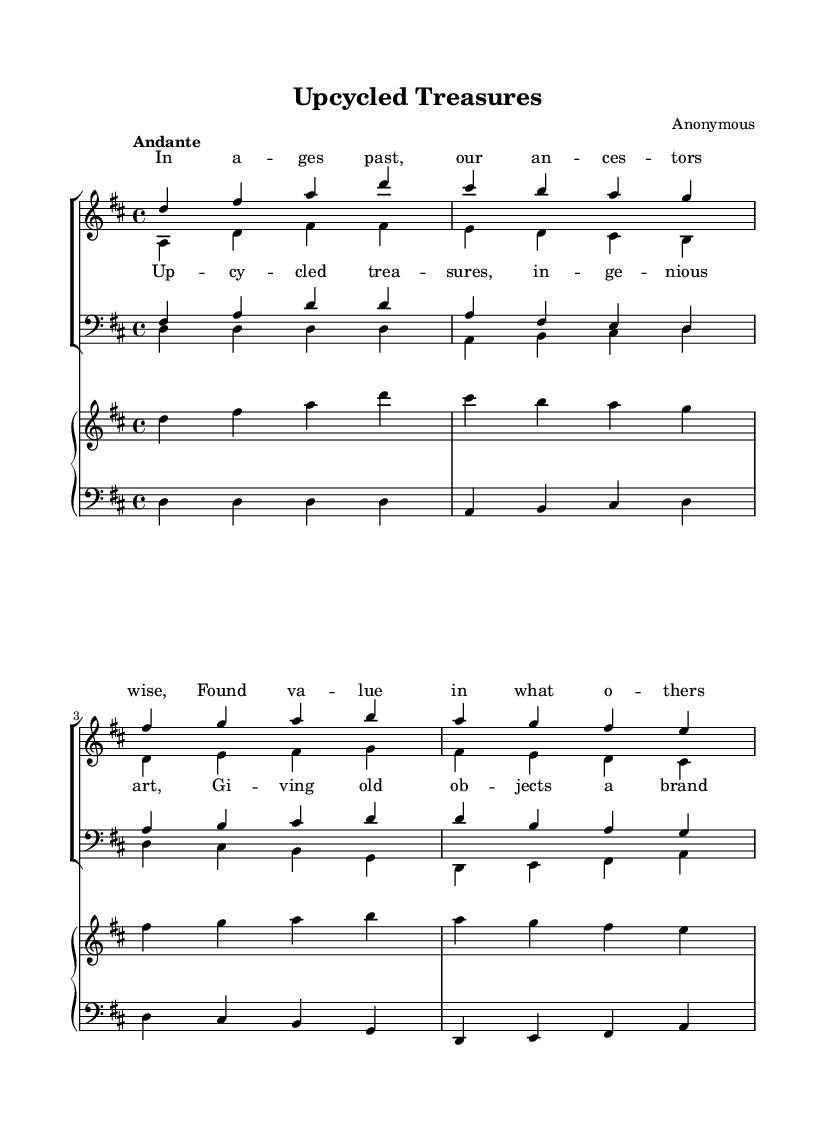What is the key signature of this music? The key signature is D major, as indicated by the two sharps (F# and C#) at the beginning of the staff.
Answer: D major What is the time signature of this music? The time signature is 4/4, shown at the beginning of the sheet music, indicating that there are four beats in each measure and each quarter note gets one beat.
Answer: 4/4 What is the tempo marking of this piece? The tempo marking is "Andante," which is indicated above the staff; it suggests a moderate pace.
Answer: Andante How many parts are there for the choir in this sheet music? The choir consists of four parts: soprano, alto, tenor, and bass, which are clearly labeled in the staff sections.
Answer: Four What do the lyrics indicate about the theme of the work? The lyrics celebrate recycling and upcycling, as they reference finding value in what others despise and creating treasures from old objects.
Answer: Recycling What type of musical piece is this? This piece is a choral work, which is indicated by the presence of multiple vocal parts and the layout for choir staff.
Answer: Choral work Which section of the music is meant to be sung by the sopranos? The soprano part is the first staff section labeled "sopranos" and includes the highest vocal line in the piece.
Answer: Soprano section 